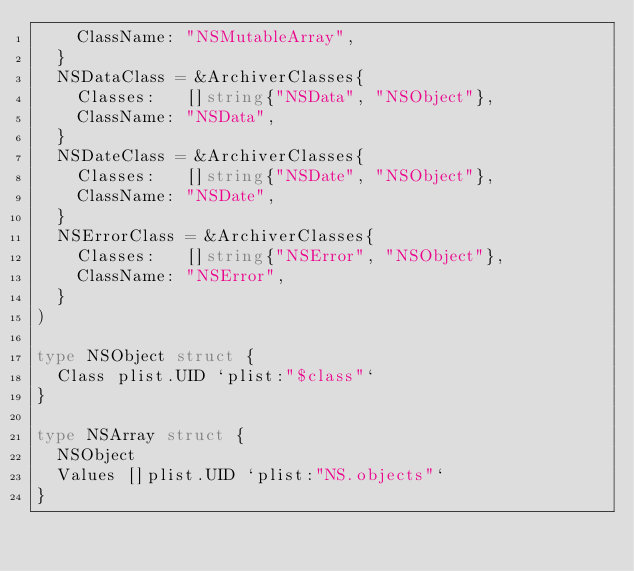Convert code to text. <code><loc_0><loc_0><loc_500><loc_500><_Go_>		ClassName: "NSMutableArray",
	}
	NSDataClass = &ArchiverClasses{
		Classes:   []string{"NSData", "NSObject"},
		ClassName: "NSData",
	}
	NSDateClass = &ArchiverClasses{
		Classes:   []string{"NSDate", "NSObject"},
		ClassName: "NSDate",
	}
	NSErrorClass = &ArchiverClasses{
		Classes:   []string{"NSError", "NSObject"},
		ClassName: "NSError",
	}
)

type NSObject struct {
	Class plist.UID `plist:"$class"`
}

type NSArray struct {
	NSObject
	Values []plist.UID `plist:"NS.objects"`
}
</code> 